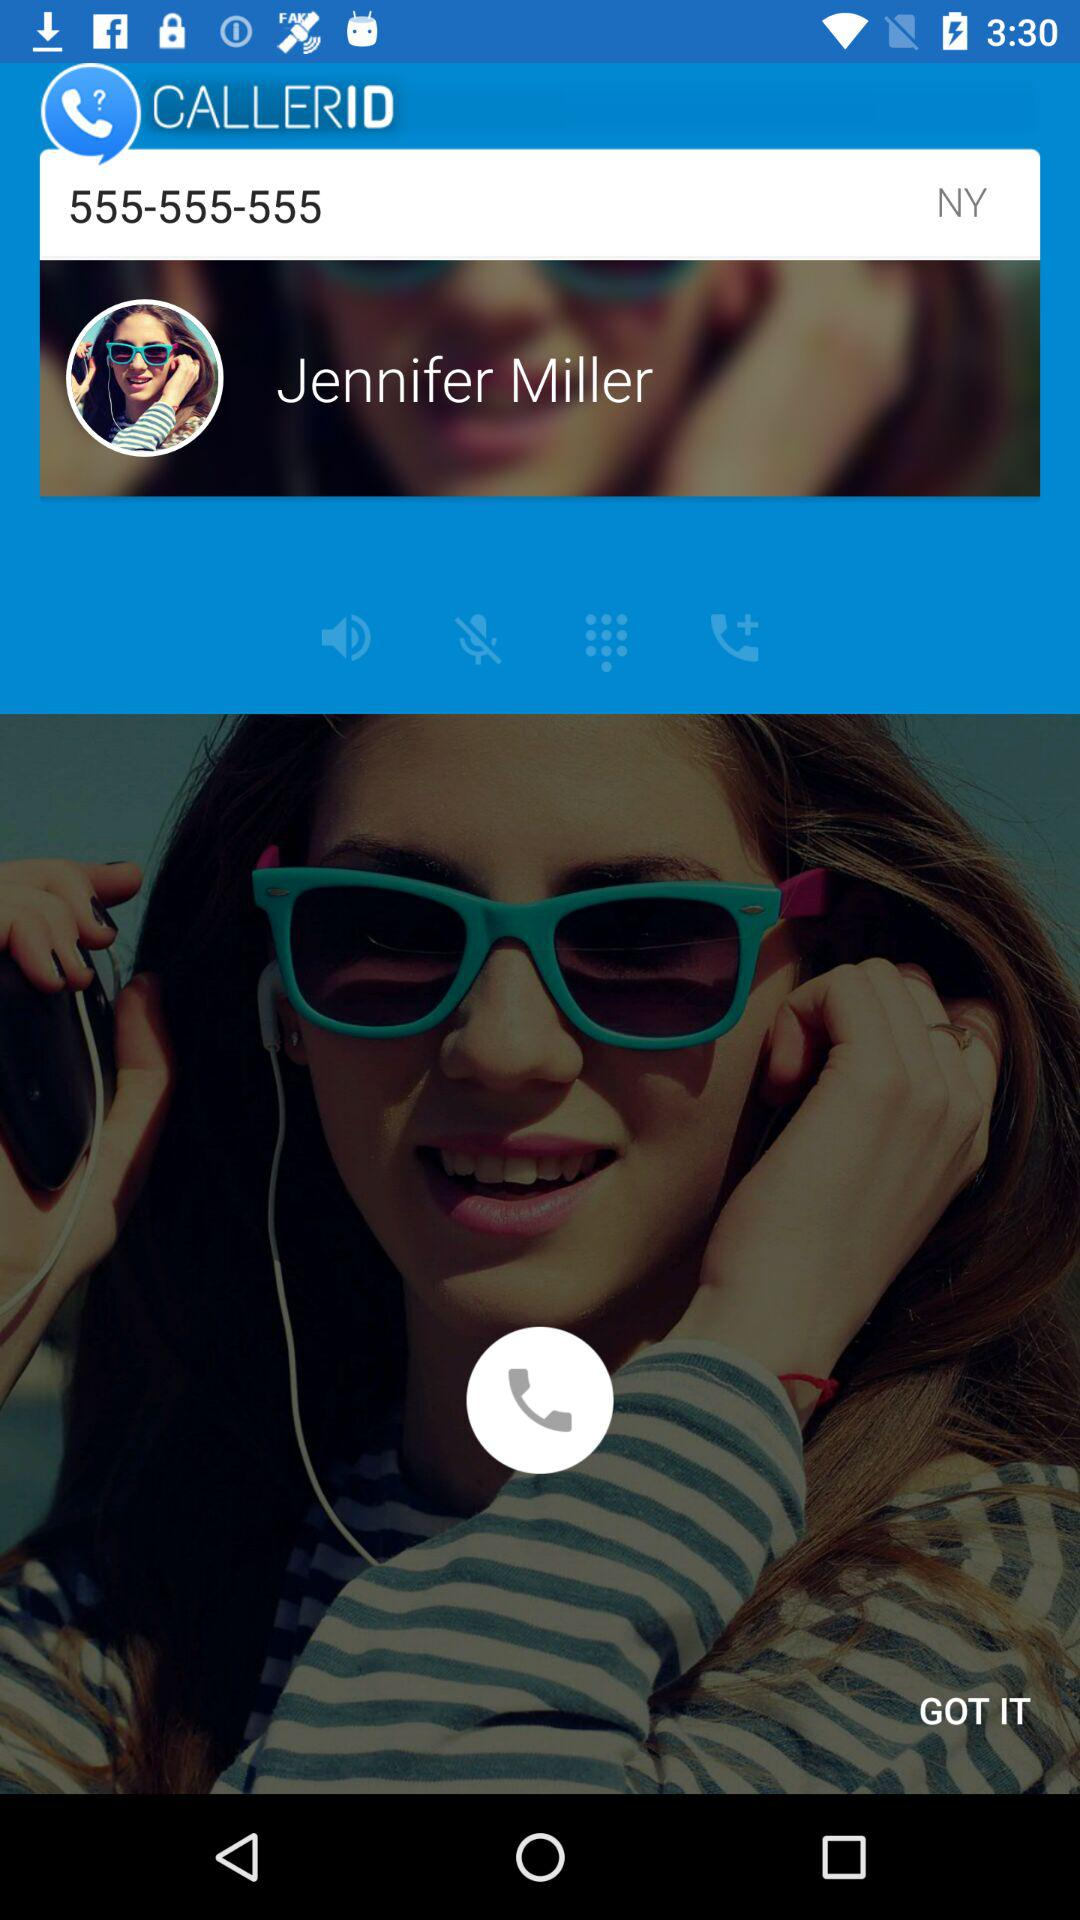What is the name of the calling person?
When the provided information is insufficient, respond with <no answer>. <no answer> 